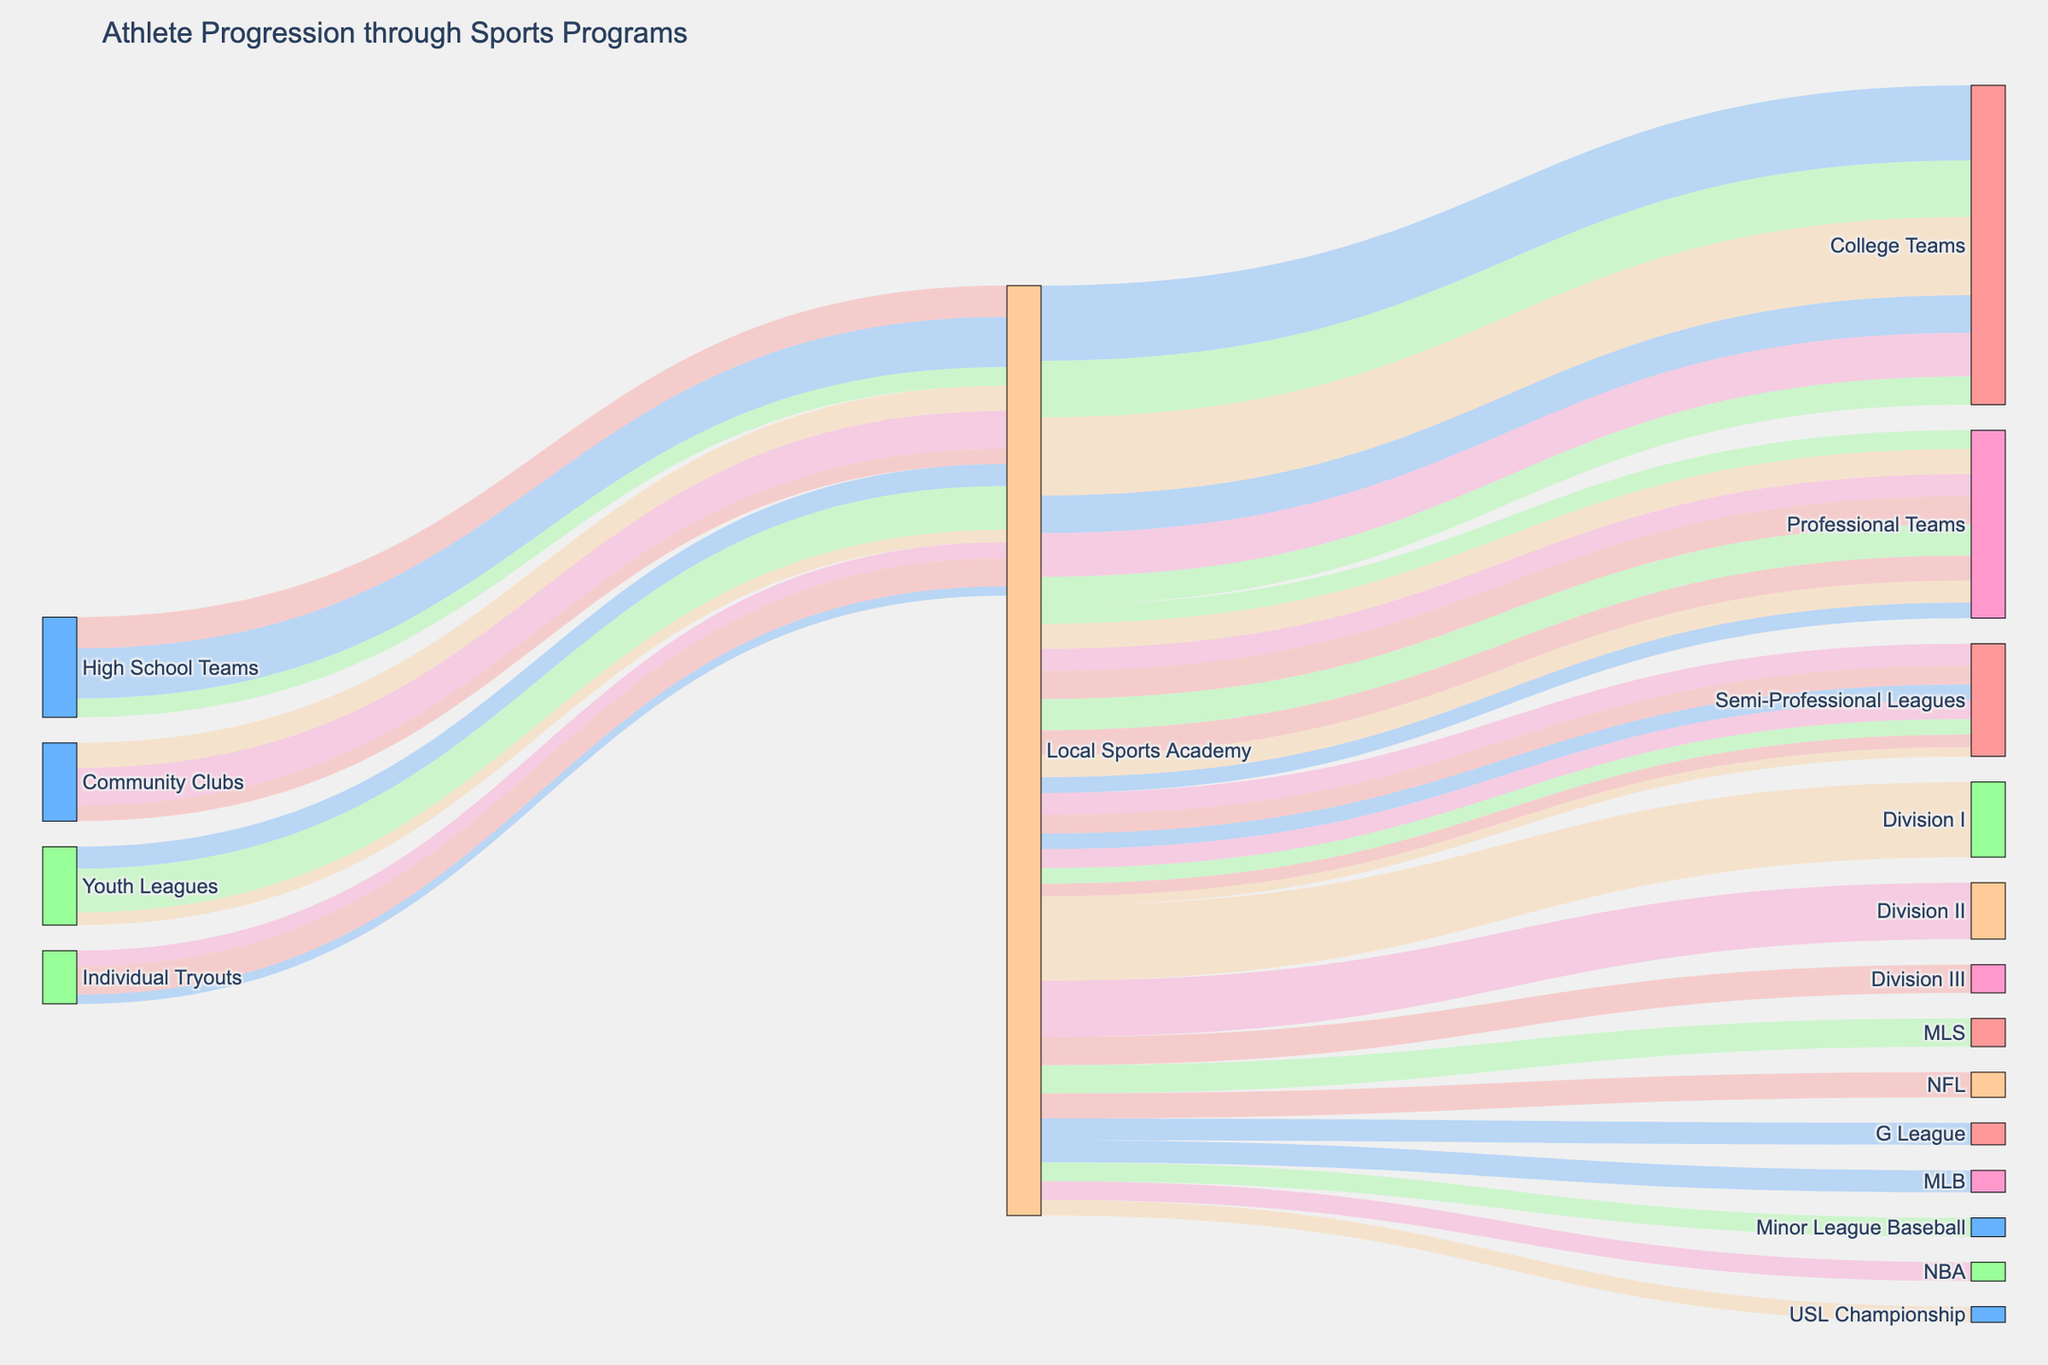How many recruitment sources are depicted in the figure? The figure shows the flow of athletes from specific recruitment sources to the Local Sports Academy. Counting the unique initial recruitment sources in the data table gives us four: High School Teams, Community Clubs, Youth Leagues, and Individual Tryouts.
Answer: Four Which destination after the Local Sports Academy has the highest number of athletes? By analyzing the flows from the Local Sports Academy to various destinations and summing the values, we see that College Teams have Division I (120), Division II (90), and Division III (45) athletes, totaling 255. This is higher than the totals for Professional Teams and Semi-Professional Leagues.
Answer: College Teams What is the total number of athletes progressing to college teams from all recruitment sources? Summing the athletes going to Local Sports Academy and then to College Teams: from High School Teams (80), Community Clubs (60), Youth Leagues (70), and Individual Tryouts (45). So, 80 + 60 + 70 + 45 = 255.
Answer: 255 Which recruitment source contributes the least number of athletes to Semi-Professional Leagues? Observing the values flowing into Semi-Professional Leagues from each recruitment source: High School Teams (30), Community Clubs (25), Youth Leagues (20), Individual Tryouts (15). The smallest number is from Individual Tryouts with 15 athletes.
Answer: Individual Tryouts Compare the number of athletes advancing from Community Clubs to Professional Teams versus Individual Tryouts to Professional Teams. Which source sends more athletes? By looking at the data, Community Clubs send 40 athletes to Professional Teams, whereas Individual Tryouts send 25. Hence, Community Clubs send more athletes than Individual Tryouts.
Answer: Community Clubs How many total athletes are recruited from High School Teams? Adding up all the athletes from High School Teams: To Professional Teams (50), College Teams (80), and Semi-Professional Leagues (30). So, 50 + 80 + 30 = 160.
Answer: 160 What is the proportional distribution of athletes advancing to different professional sports leagues? Summing up the totals for NBA, NFL, MLB, and MLS, we have 150 athletes (30 + 40 + 35 + 45). The proportional distribution can be calculated as: NBA (30/150 = 20%), NFL (40/150 = 26.67%), MLB (35/150 = 23.33%), MLS (45/150 = 30%).
Answer: NBA: 20%, NFL: 26.67%, MLB: 23.33%, MLS: 30% Is the number of athletes from Youth Leagues to College Teams greater than the combined number of athletes from Community Clubs to Semi-Professional Leagues? Comparing the values, Youth Leagues send 70 athletes to College Teams, while Community Clubs send a combined total of 25 athletes to Semi-Professional Leagues. Since 70 is greater than 25, the statement is true.
Answer: Yes Which pathway has the highest single flow of athletes? By examining each pathway, the route from the Local Sports Academy to Division I College Teams has the highest single flow with 120 athletes.
Answer: Local Sports Academy to Division I College Teams How many athletes make the journey through Local Sports Academy to Semi-Professional Leagues from all sources? Summing the values going to G League (35), Minor League Baseball (30), and USL Championship (25). So, 35 + 30 + 25 = 90.
Answer: 90 